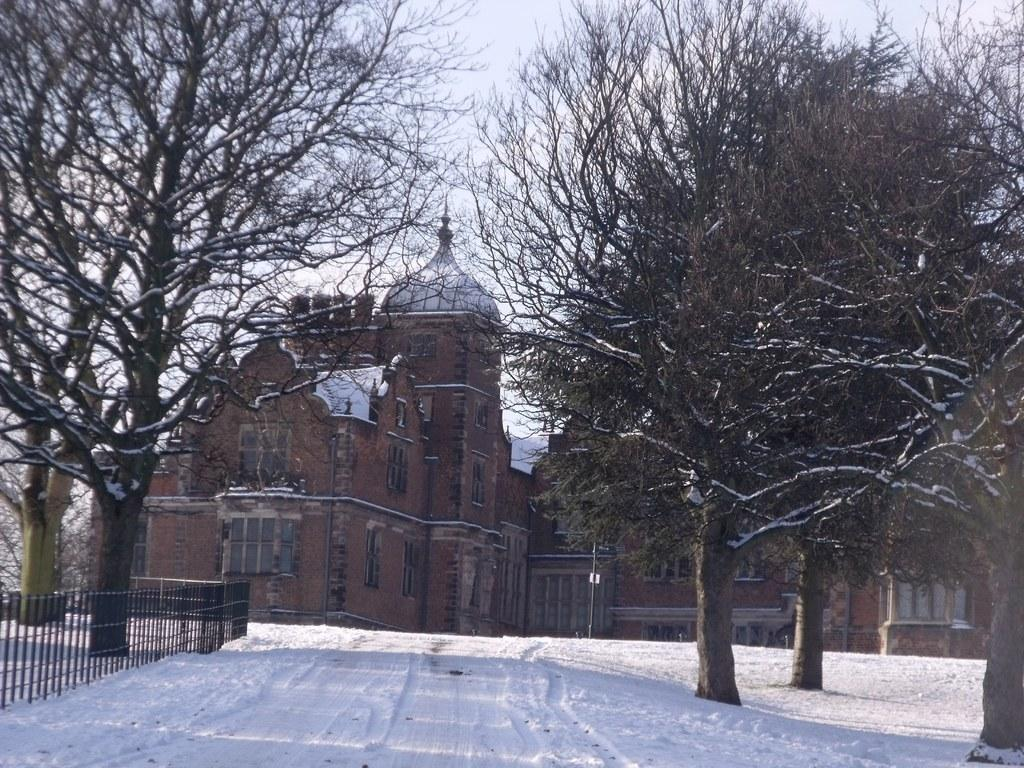What type of structure is visible in the image? There is a building with windows in the image. What can be seen on the left side of the image? There is a fence on the left side of the image. What is located in the background of the image? There is a group of trees and the sky visible in the background of the image. What type of butter is being used to paint the fence in the image? There is no butter present in the image, and the fence is not being painted. 